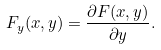Convert formula to latex. <formula><loc_0><loc_0><loc_500><loc_500>F _ { y } ( x , y ) = \frac { \partial F ( x , y ) } { \partial y } .</formula> 